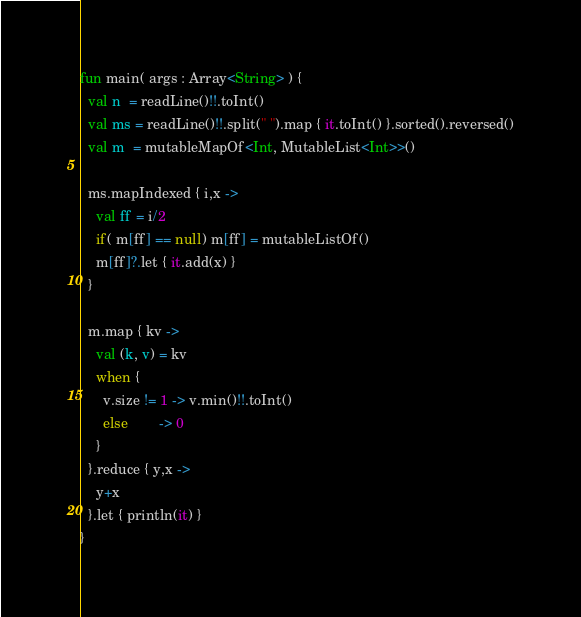Convert code to text. <code><loc_0><loc_0><loc_500><loc_500><_Kotlin_>fun main( args : Array<String> ) { 
  val n  = readLine()!!.toInt()
  val ms = readLine()!!.split(" ").map { it.toInt() }.sorted().reversed()
  val m  = mutableMapOf<Int, MutableList<Int>>()

  ms.mapIndexed { i,x -> 
    val ff = i/2
    if( m[ff] == null) m[ff] = mutableListOf()
    m[ff]?.let { it.add(x) }
  }

  m.map { kv -> 
    val (k, v) = kv
    when { 
      v.size != 1 -> v.min()!!.toInt()
      else        -> 0
    }
  }.reduce { y,x ->
    y+x
  }.let { println(it) }
}
</code> 